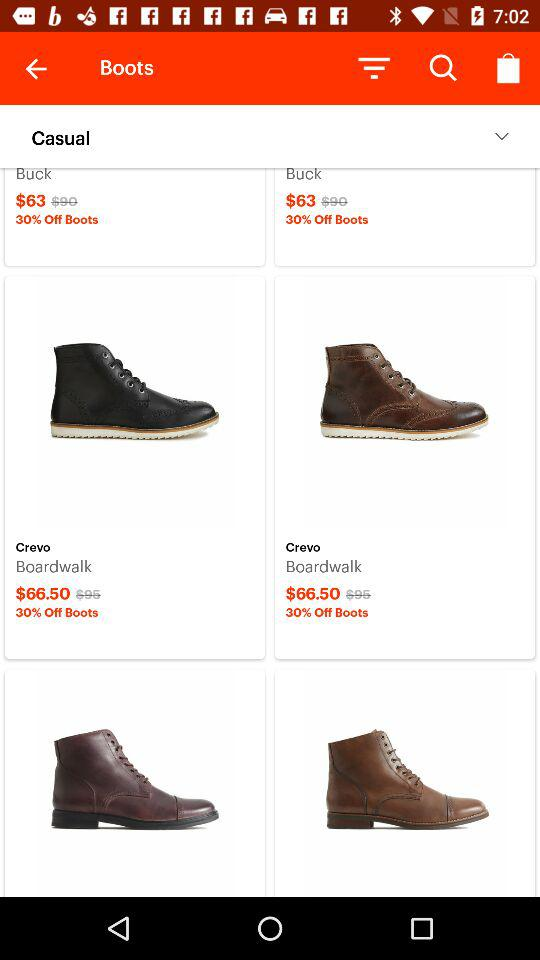How much of a percentage is a discount on Board Walk? The discount percentage is 30. 